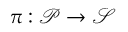Convert formula to latex. <formula><loc_0><loc_0><loc_500><loc_500>\pi \colon \mathcal { P } { \rightarrow } \mathcal { S }</formula> 